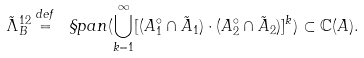Convert formula to latex. <formula><loc_0><loc_0><loc_500><loc_500>\tilde { \Lambda } _ { B } ^ { 1 2 } \overset { d e f } { = } \ \S p a n ( \underset { k = 1 } { \overset { \infty } { \bigcup } } [ ( A _ { 1 } ^ { \circ } \cap \tilde { A } _ { 1 } ) \cdot ( A _ { 2 } ^ { \circ } \cap \tilde { A } _ { 2 } ) ] ^ { k } ) \subset \mathbb { C } ( A ) .</formula> 